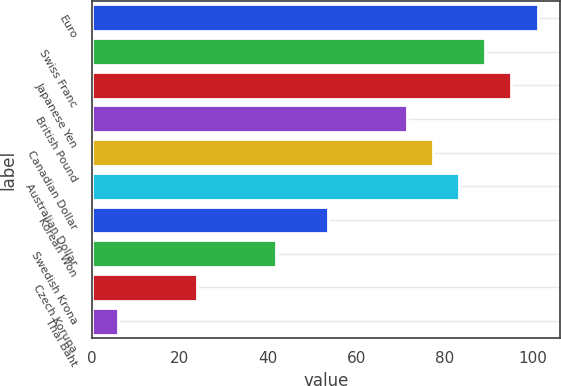<chart> <loc_0><loc_0><loc_500><loc_500><bar_chart><fcel>Euro<fcel>Swiss Franc<fcel>Japanese Yen<fcel>British Pound<fcel>Canadian Dollar<fcel>Australian Dollar<fcel>Korean Won<fcel>Swedish Krona<fcel>Czech Koruna<fcel>Thai Baht<nl><fcel>101.08<fcel>89.2<fcel>95.14<fcel>71.38<fcel>77.32<fcel>83.26<fcel>53.56<fcel>41.68<fcel>23.86<fcel>6.04<nl></chart> 